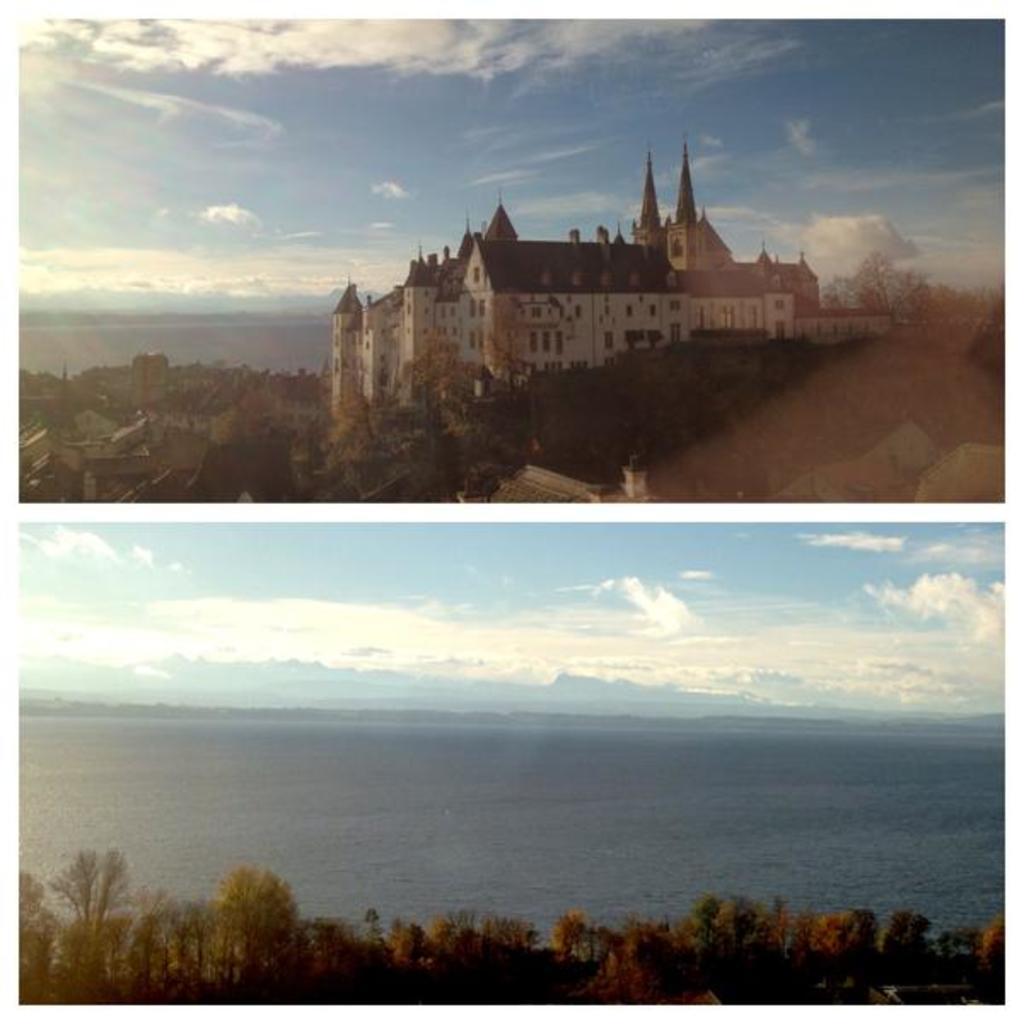Please provide a concise description of this image. This is a collage picture. I can see the buildings, trees, sea and the sky. 